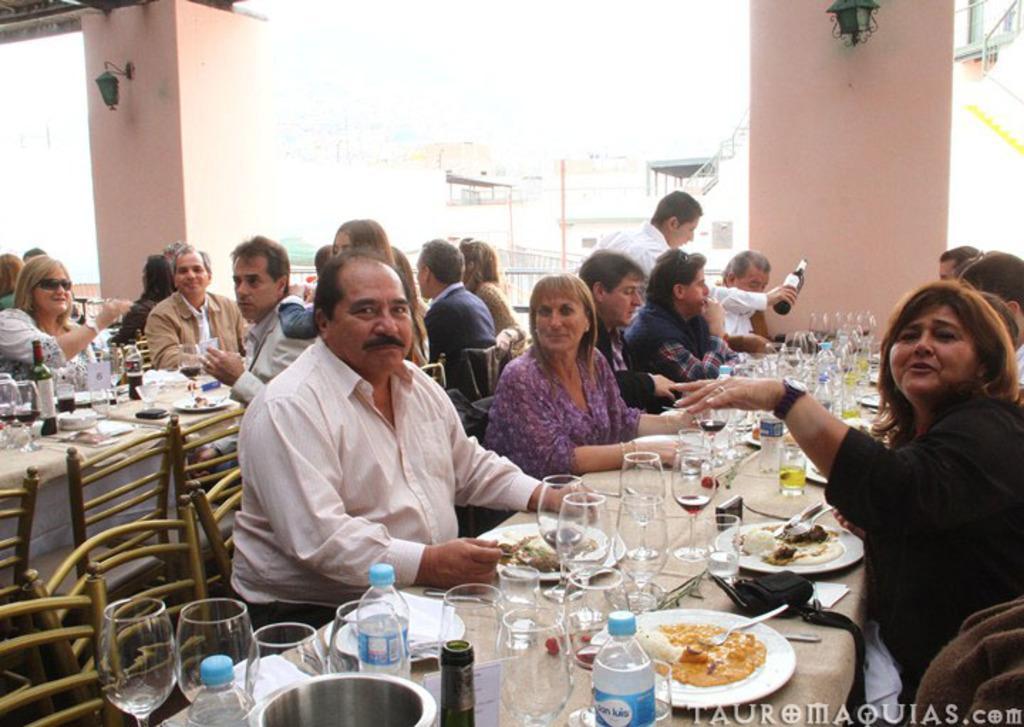Describe this image in one or two sentences. In this picture there are so many people are sitting on the chair in front of them there is a table on the table there are so many bottles classes plates and some of the eatable things at the backside one person is holding a bottle and they are taking a picture. 